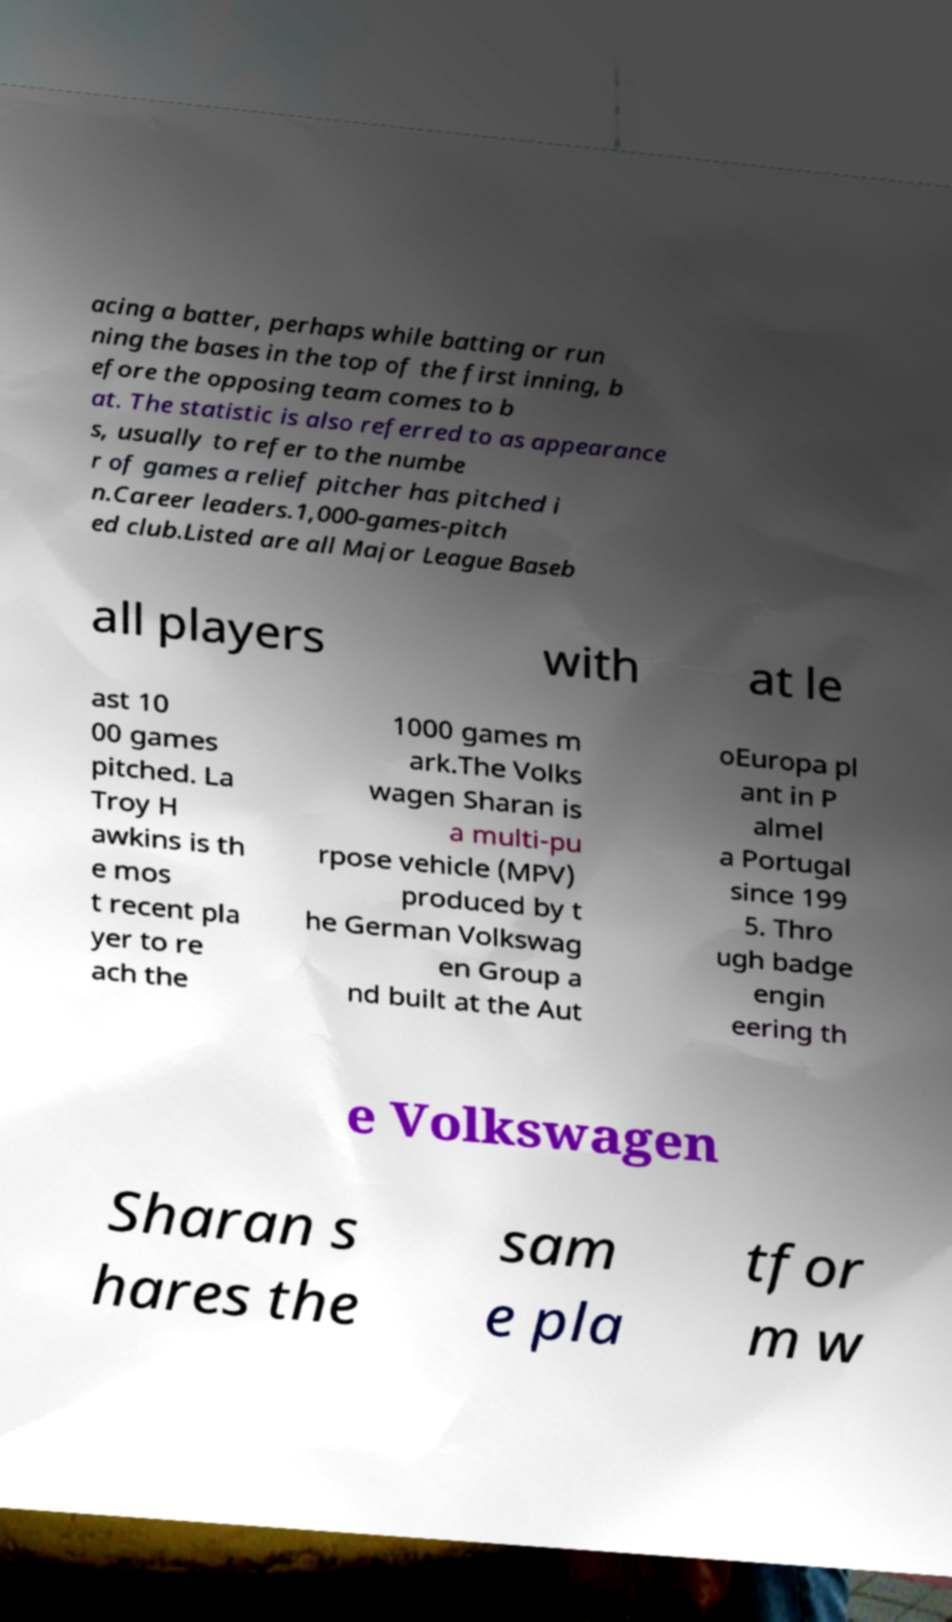Could you assist in decoding the text presented in this image and type it out clearly? acing a batter, perhaps while batting or run ning the bases in the top of the first inning, b efore the opposing team comes to b at. The statistic is also referred to as appearance s, usually to refer to the numbe r of games a relief pitcher has pitched i n.Career leaders.1,000-games-pitch ed club.Listed are all Major League Baseb all players with at le ast 10 00 games pitched. La Troy H awkins is th e mos t recent pla yer to re ach the 1000 games m ark.The Volks wagen Sharan is a multi-pu rpose vehicle (MPV) produced by t he German Volkswag en Group a nd built at the Aut oEuropa pl ant in P almel a Portugal since 199 5. Thro ugh badge engin eering th e Volkswagen Sharan s hares the sam e pla tfor m w 